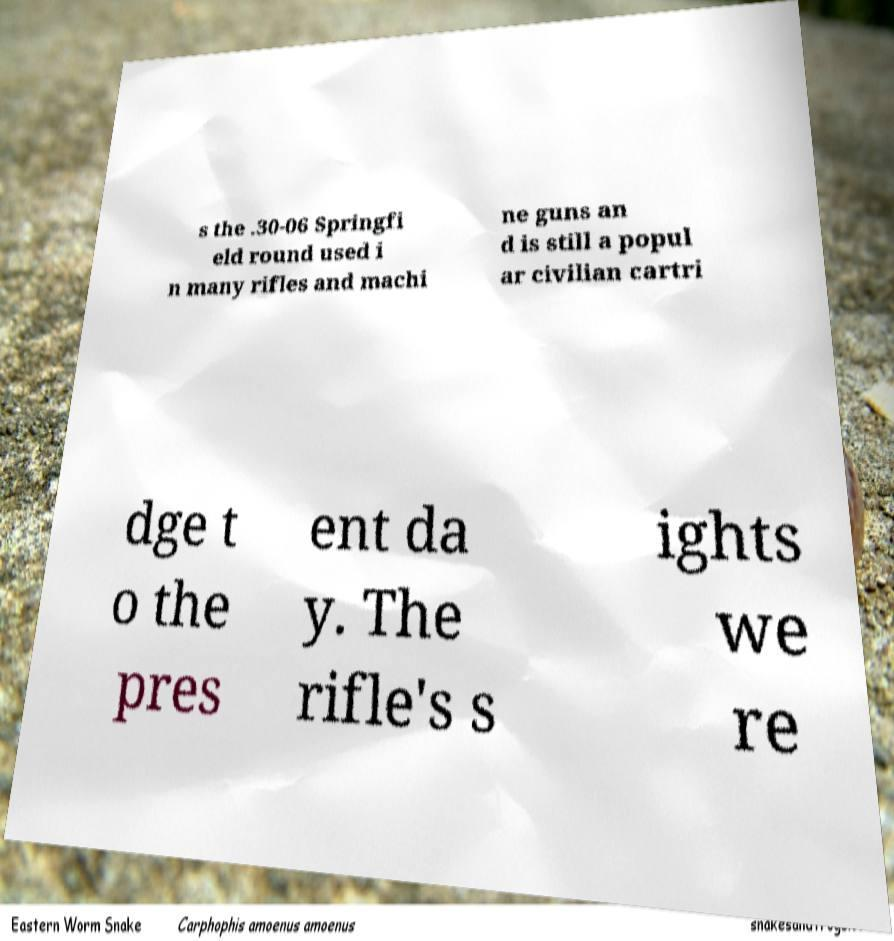Could you assist in decoding the text presented in this image and type it out clearly? s the .30-06 Springfi eld round used i n many rifles and machi ne guns an d is still a popul ar civilian cartri dge t o the pres ent da y. The rifle's s ights we re 